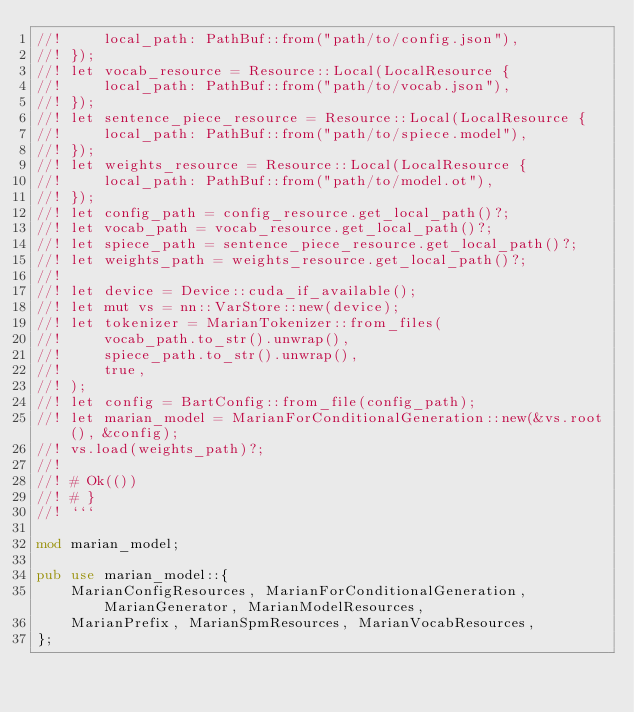Convert code to text. <code><loc_0><loc_0><loc_500><loc_500><_Rust_>//!     local_path: PathBuf::from("path/to/config.json"),
//! });
//! let vocab_resource = Resource::Local(LocalResource {
//!     local_path: PathBuf::from("path/to/vocab.json"),
//! });
//! let sentence_piece_resource = Resource::Local(LocalResource {
//!     local_path: PathBuf::from("path/to/spiece.model"),
//! });
//! let weights_resource = Resource::Local(LocalResource {
//!     local_path: PathBuf::from("path/to/model.ot"),
//! });
//! let config_path = config_resource.get_local_path()?;
//! let vocab_path = vocab_resource.get_local_path()?;
//! let spiece_path = sentence_piece_resource.get_local_path()?;
//! let weights_path = weights_resource.get_local_path()?;
//!
//! let device = Device::cuda_if_available();
//! let mut vs = nn::VarStore::new(device);
//! let tokenizer = MarianTokenizer::from_files(
//!     vocab_path.to_str().unwrap(),
//!     spiece_path.to_str().unwrap(),
//!     true,
//! );
//! let config = BartConfig::from_file(config_path);
//! let marian_model = MarianForConditionalGeneration::new(&vs.root(), &config);
//! vs.load(weights_path)?;
//!
//! # Ok(())
//! # }
//! ```

mod marian_model;

pub use marian_model::{
    MarianConfigResources, MarianForConditionalGeneration, MarianGenerator, MarianModelResources,
    MarianPrefix, MarianSpmResources, MarianVocabResources,
};
</code> 